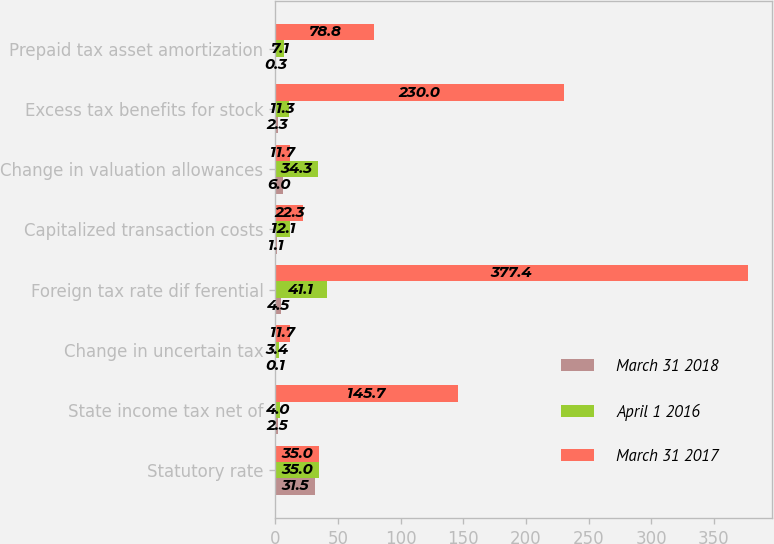Convert chart to OTSL. <chart><loc_0><loc_0><loc_500><loc_500><stacked_bar_chart><ecel><fcel>Statutory rate<fcel>State income tax net of<fcel>Change in uncertain tax<fcel>Foreign tax rate dif ferential<fcel>Capitalized transaction costs<fcel>Change in valuation allowances<fcel>Excess tax benefits for stock<fcel>Prepaid tax asset amortization<nl><fcel>March 31 2018<fcel>31.5<fcel>2.5<fcel>0.1<fcel>4.5<fcel>1.1<fcel>6<fcel>2.3<fcel>0.3<nl><fcel>April 1 2016<fcel>35<fcel>4<fcel>3.4<fcel>41.1<fcel>12.1<fcel>34.3<fcel>11.3<fcel>7.1<nl><fcel>March 31 2017<fcel>35<fcel>145.7<fcel>11.7<fcel>377.4<fcel>22.3<fcel>11.7<fcel>230<fcel>78.8<nl></chart> 